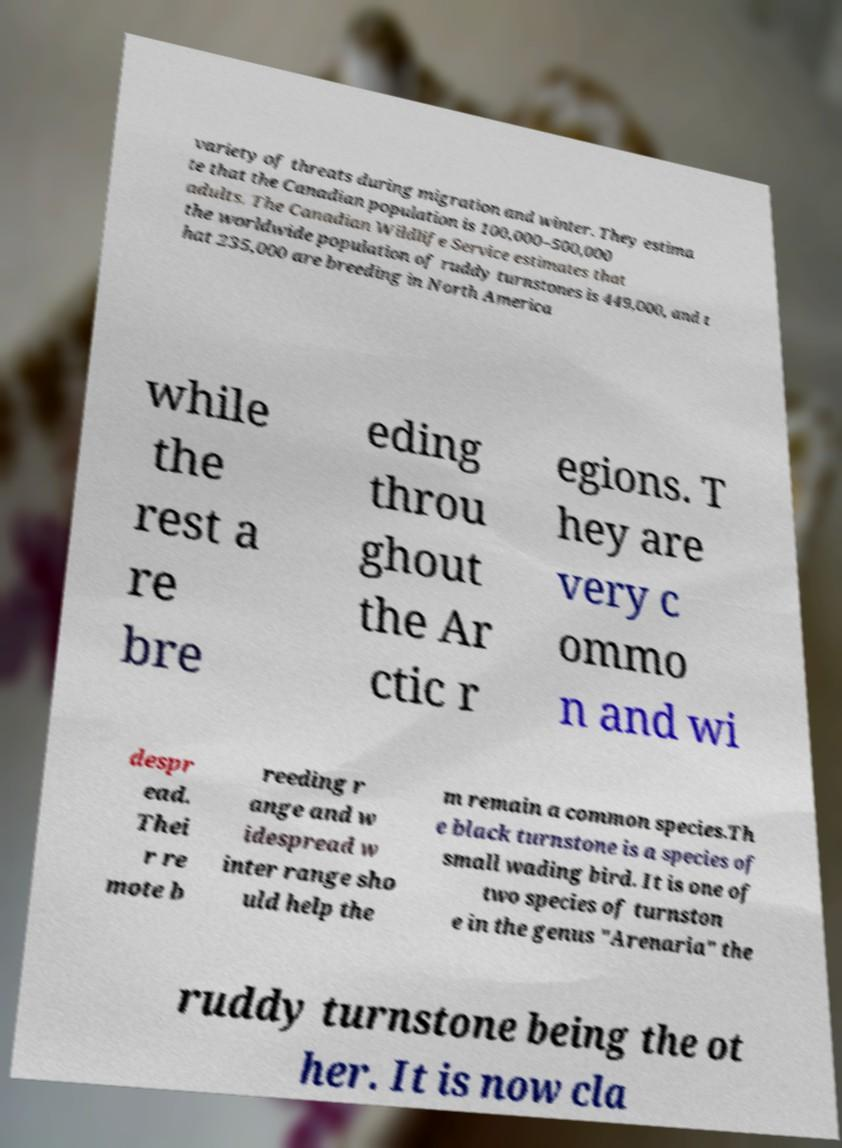I need the written content from this picture converted into text. Can you do that? variety of threats during migration and winter. They estima te that the Canadian population is 100,000–500,000 adults. The Canadian Wildlife Service estimates that the worldwide population of ruddy turnstones is 449,000, and t hat 235,000 are breeding in North America while the rest a re bre eding throu ghout the Ar ctic r egions. T hey are very c ommo n and wi despr ead. Thei r re mote b reeding r ange and w idespread w inter range sho uld help the m remain a common species.Th e black turnstone is a species of small wading bird. It is one of two species of turnston e in the genus "Arenaria" the ruddy turnstone being the ot her. It is now cla 